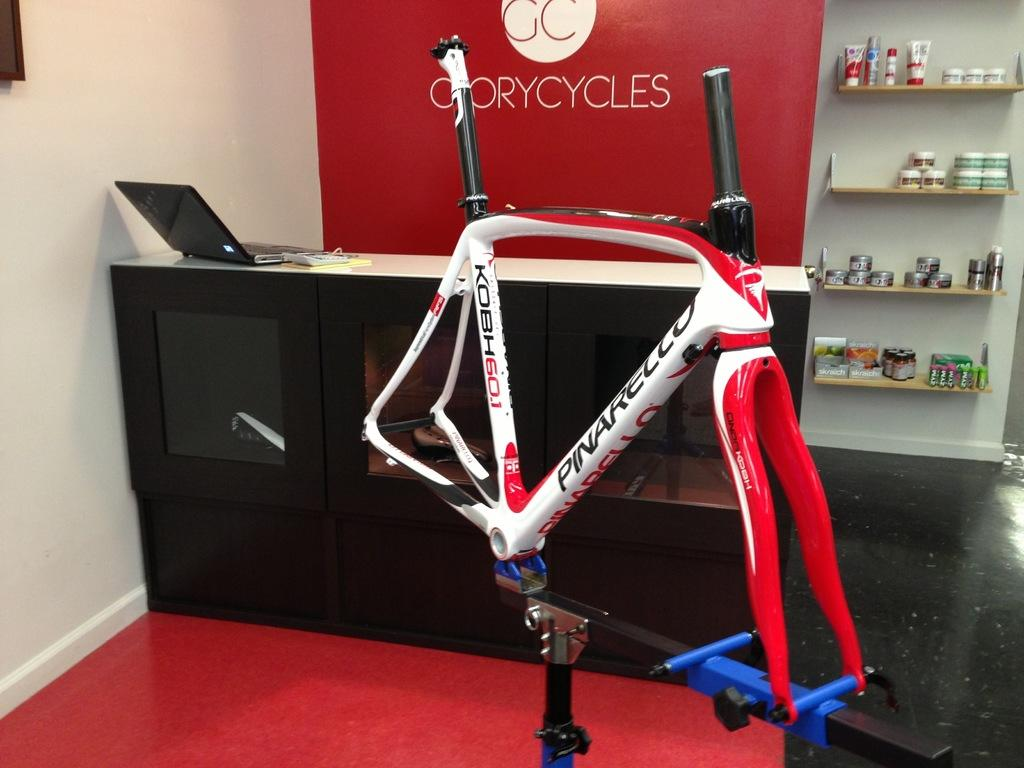<image>
Provide a brief description of the given image. A Pinarello bike frame is mounted in the store. 